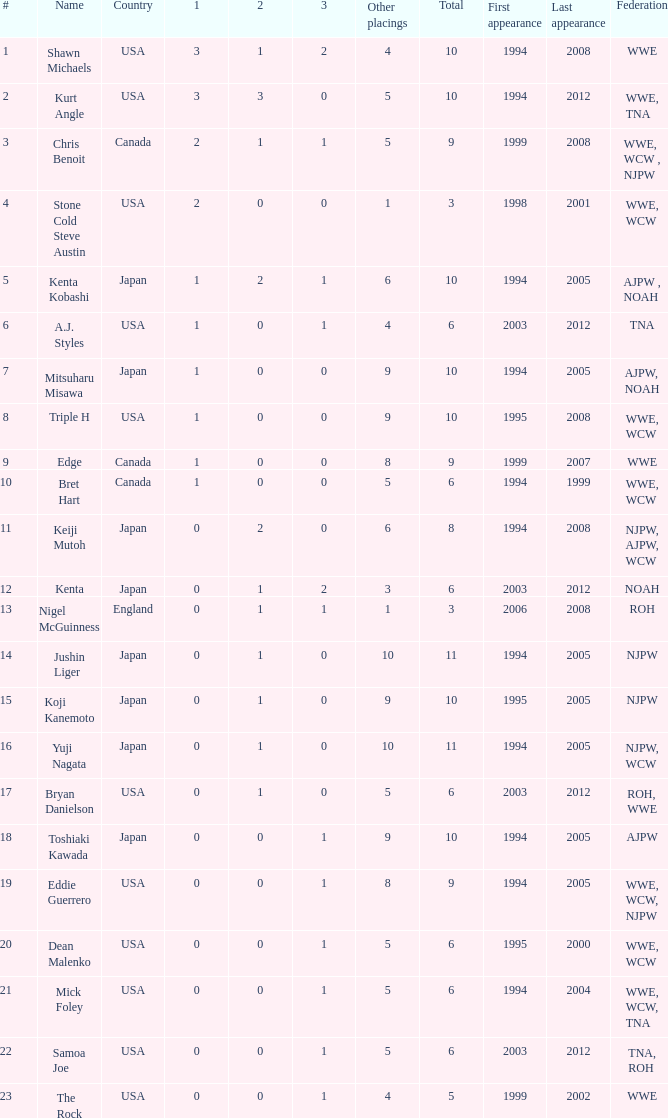In this event, how many times has a wrestler from the roh or wwe federation participated? 1.0. 